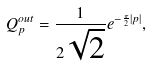<formula> <loc_0><loc_0><loc_500><loc_500>Q _ { p } ^ { o u t } = \frac { 1 } { 2 \sqrt { 2 } } e ^ { - \frac { \pi } { 2 } | p | } ,</formula> 